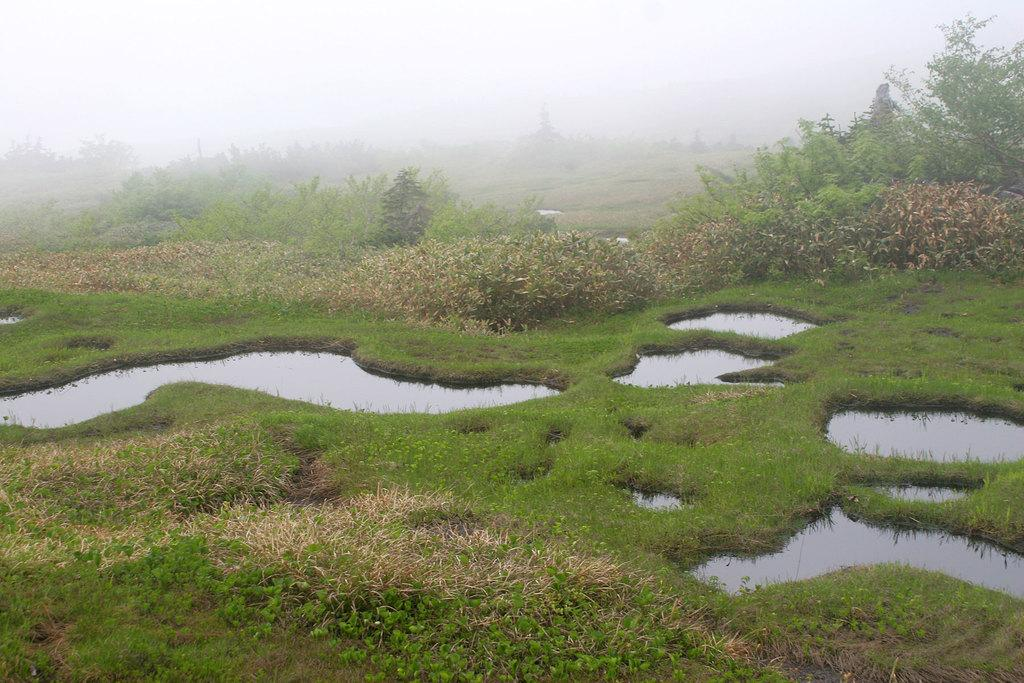What is the primary element visible in the image? There is water in the image. What type of vegetation can be seen in the image? There is grass and a group of plants in the image. What can be seen in the background of the image? There is a group of trees and the sky visible in the background of the image. What type of guitar can be seen in the image? There is no guitar present in the image. Is there a pocket visible in the image? There is no pocket visible in the image. 